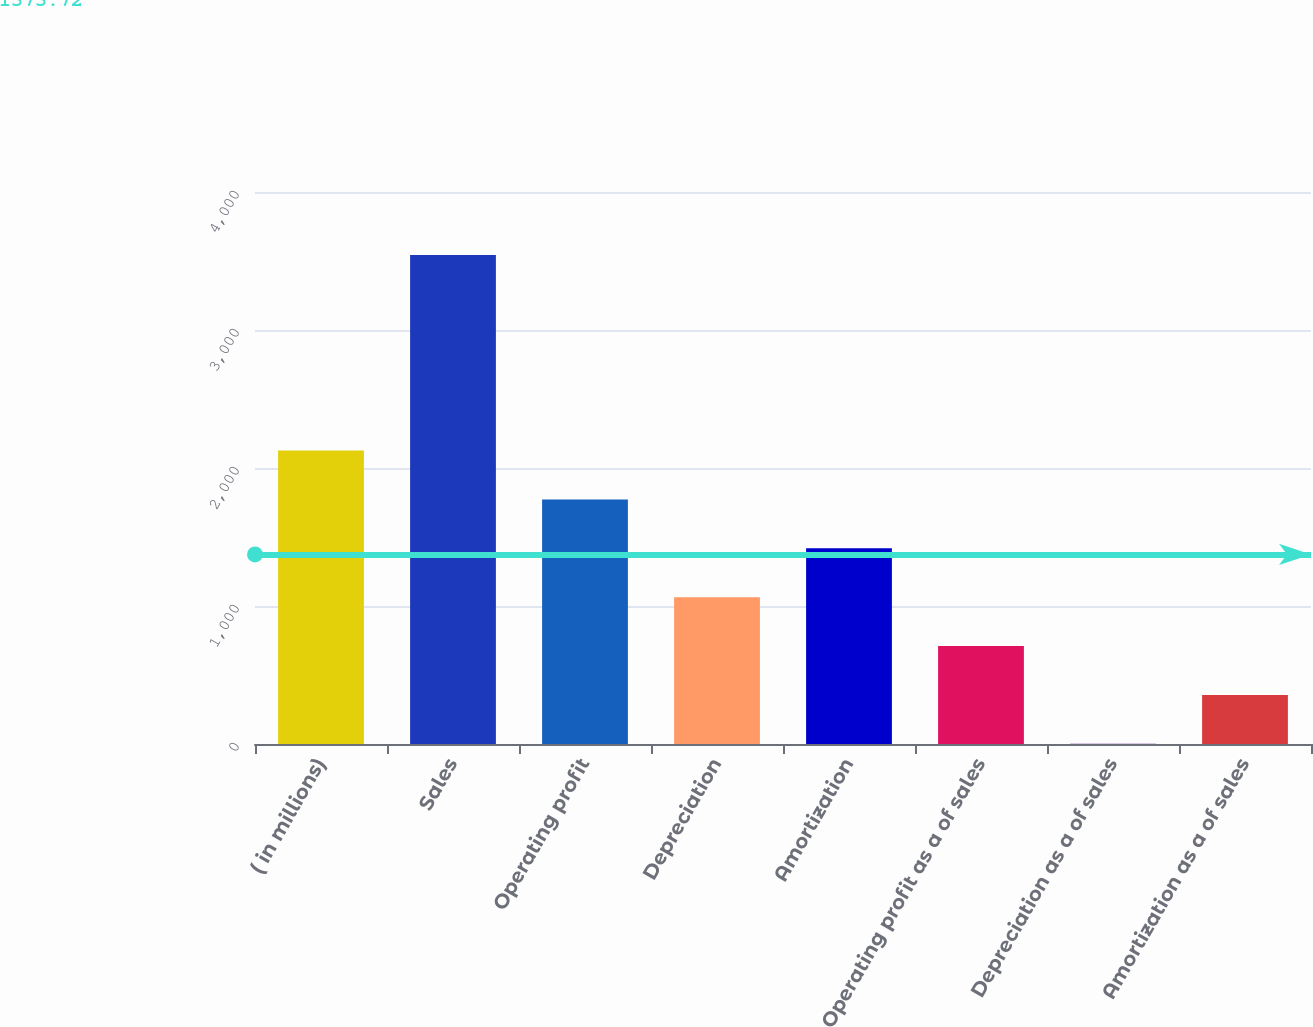Convert chart. <chart><loc_0><loc_0><loc_500><loc_500><bar_chart><fcel>( in millions)<fcel>Sales<fcel>Operating profit<fcel>Depreciation<fcel>Amortization<fcel>Operating profit as a of sales<fcel>Depreciation as a of sales<fcel>Amortization as a of sales<nl><fcel>2126.5<fcel>3543.5<fcel>1772.25<fcel>1063.75<fcel>1418<fcel>709.5<fcel>1<fcel>355.25<nl></chart> 